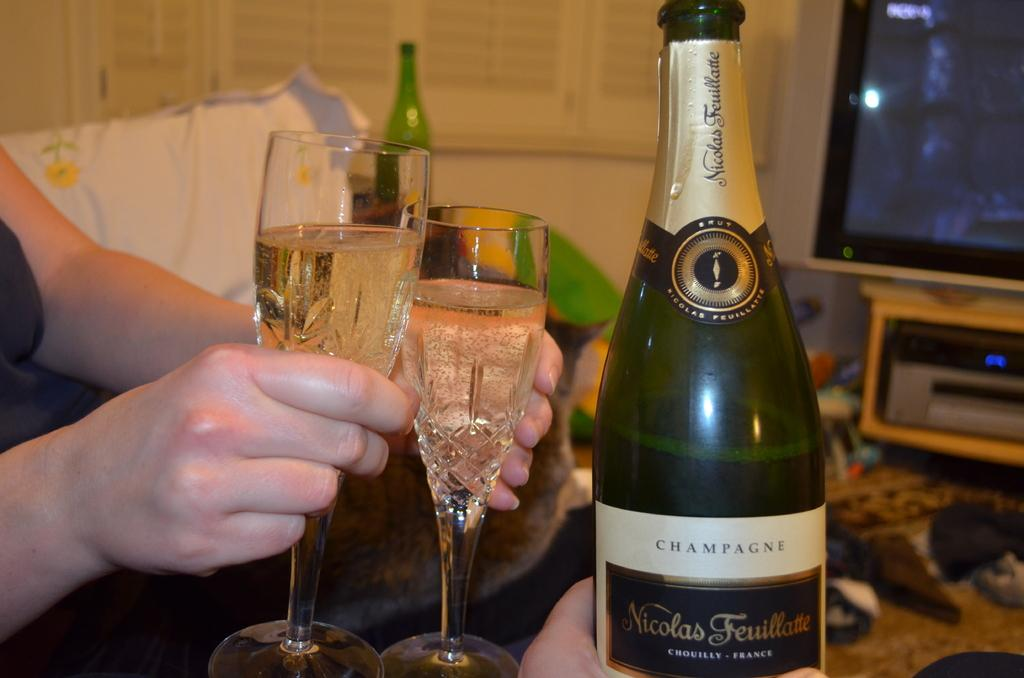<image>
Relay a brief, clear account of the picture shown. Two mostly full wine glasses of Nicolas Feuillatte champagne being enjoyed in front of a television. 